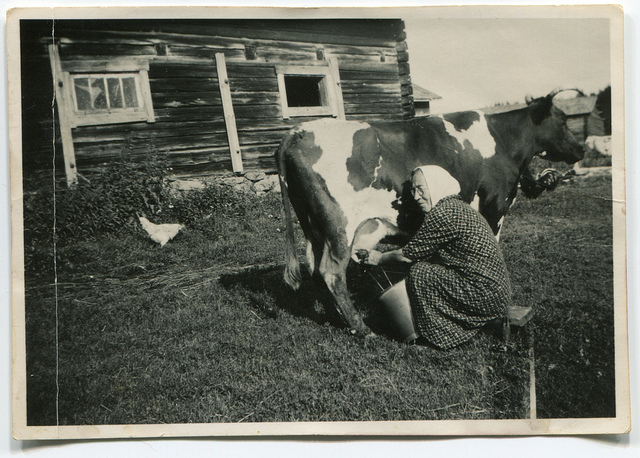<image>What color is the lady's bonnet? I am not sure about the color of the lady's bonnet. It might be white. What color is the lady's bonnet? The lady's bonnet is white. 